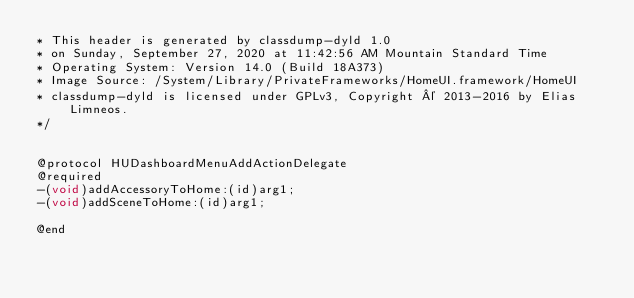<code> <loc_0><loc_0><loc_500><loc_500><_C_>* This header is generated by classdump-dyld 1.0
* on Sunday, September 27, 2020 at 11:42:56 AM Mountain Standard Time
* Operating System: Version 14.0 (Build 18A373)
* Image Source: /System/Library/PrivateFrameworks/HomeUI.framework/HomeUI
* classdump-dyld is licensed under GPLv3, Copyright © 2013-2016 by Elias Limneos.
*/


@protocol HUDashboardMenuAddActionDelegate
@required
-(void)addAccessoryToHome:(id)arg1;
-(void)addSceneToHome:(id)arg1;

@end

</code> 